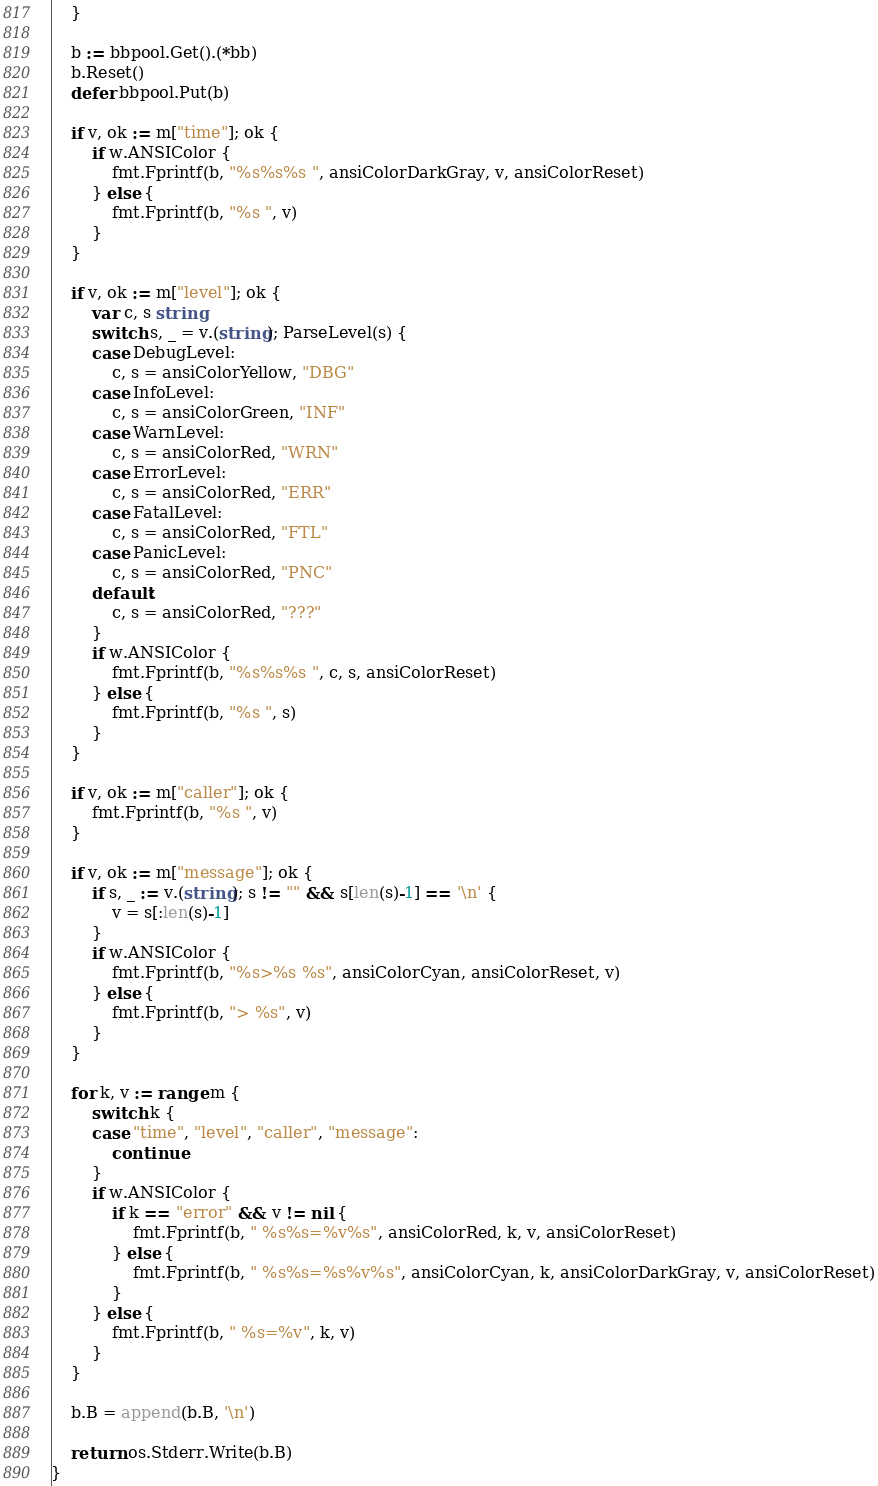<code> <loc_0><loc_0><loc_500><loc_500><_Go_>	}

	b := bbpool.Get().(*bb)
	b.Reset()
	defer bbpool.Put(b)

	if v, ok := m["time"]; ok {
		if w.ANSIColor {
			fmt.Fprintf(b, "%s%s%s ", ansiColorDarkGray, v, ansiColorReset)
		} else {
			fmt.Fprintf(b, "%s ", v)
		}
	}

	if v, ok := m["level"]; ok {
		var c, s string
		switch s, _ = v.(string); ParseLevel(s) {
		case DebugLevel:
			c, s = ansiColorYellow, "DBG"
		case InfoLevel:
			c, s = ansiColorGreen, "INF"
		case WarnLevel:
			c, s = ansiColorRed, "WRN"
		case ErrorLevel:
			c, s = ansiColorRed, "ERR"
		case FatalLevel:
			c, s = ansiColorRed, "FTL"
		case PanicLevel:
			c, s = ansiColorRed, "PNC"
		default:
			c, s = ansiColorRed, "???"
		}
		if w.ANSIColor {
			fmt.Fprintf(b, "%s%s%s ", c, s, ansiColorReset)
		} else {
			fmt.Fprintf(b, "%s ", s)
		}
	}

	if v, ok := m["caller"]; ok {
		fmt.Fprintf(b, "%s ", v)
	}

	if v, ok := m["message"]; ok {
		if s, _ := v.(string); s != "" && s[len(s)-1] == '\n' {
			v = s[:len(s)-1]
		}
		if w.ANSIColor {
			fmt.Fprintf(b, "%s>%s %s", ansiColorCyan, ansiColorReset, v)
		} else {
			fmt.Fprintf(b, "> %s", v)
		}
	}

	for k, v := range m {
		switch k {
		case "time", "level", "caller", "message":
			continue
		}
		if w.ANSIColor {
			if k == "error" && v != nil {
				fmt.Fprintf(b, " %s%s=%v%s", ansiColorRed, k, v, ansiColorReset)
			} else {
				fmt.Fprintf(b, " %s%s=%s%v%s", ansiColorCyan, k, ansiColorDarkGray, v, ansiColorReset)
			}
		} else {
			fmt.Fprintf(b, " %s=%v", k, v)
		}
	}

	b.B = append(b.B, '\n')

	return os.Stderr.Write(b.B)
}
</code> 